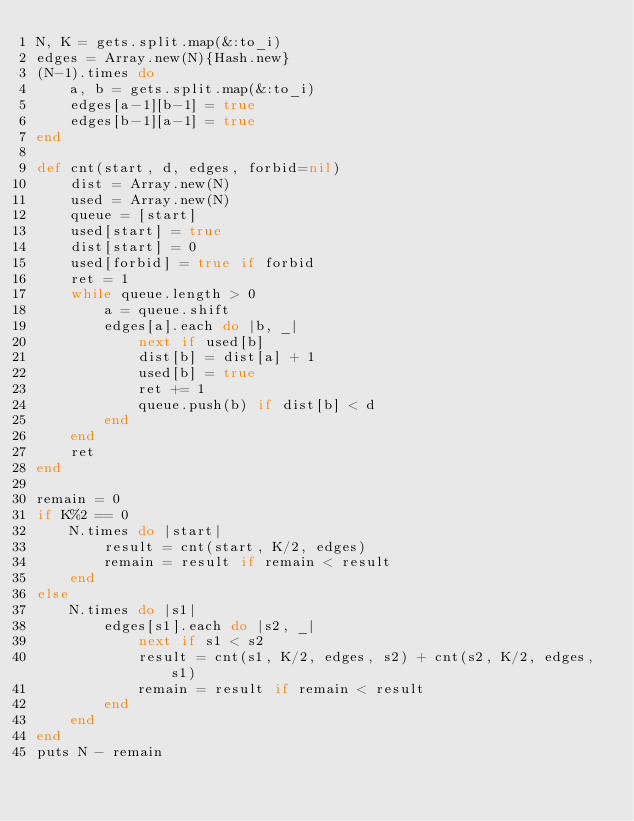<code> <loc_0><loc_0><loc_500><loc_500><_Ruby_>N, K = gets.split.map(&:to_i)
edges = Array.new(N){Hash.new}
(N-1).times do
    a, b = gets.split.map(&:to_i)
    edges[a-1][b-1] = true
    edges[b-1][a-1] = true
end

def cnt(start, d, edges, forbid=nil)
    dist = Array.new(N)
    used = Array.new(N)
    queue = [start]
    used[start] = true
    dist[start] = 0
    used[forbid] = true if forbid
    ret = 1
    while queue.length > 0
        a = queue.shift
        edges[a].each do |b, _|
            next if used[b]
            dist[b] = dist[a] + 1
            used[b] = true
            ret += 1
            queue.push(b) if dist[b] < d
        end
    end
    ret
end

remain = 0
if K%2 == 0
    N.times do |start|
        result = cnt(start, K/2, edges)
        remain = result if remain < result
    end
else
    N.times do |s1|
        edges[s1].each do |s2, _|
            next if s1 < s2
            result = cnt(s1, K/2, edges, s2) + cnt(s2, K/2, edges, s1)
            remain = result if remain < result
        end
    end
end
puts N - remain</code> 